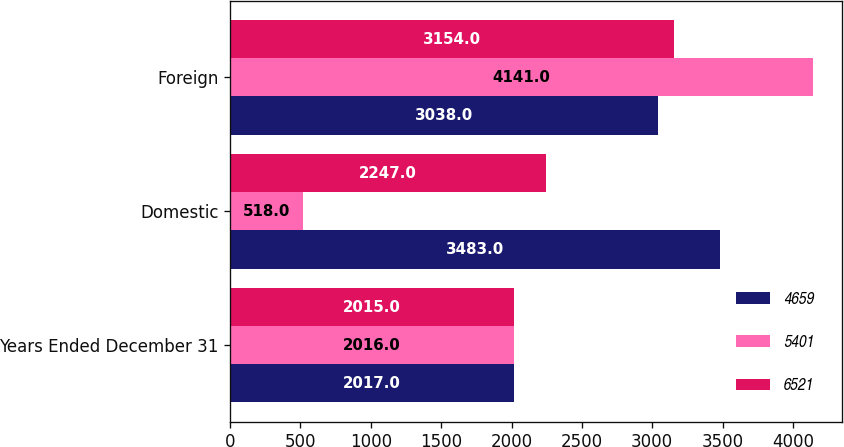Convert chart to OTSL. <chart><loc_0><loc_0><loc_500><loc_500><stacked_bar_chart><ecel><fcel>Years Ended December 31<fcel>Domestic<fcel>Foreign<nl><fcel>4659<fcel>2017<fcel>3483<fcel>3038<nl><fcel>5401<fcel>2016<fcel>518<fcel>4141<nl><fcel>6521<fcel>2015<fcel>2247<fcel>3154<nl></chart> 